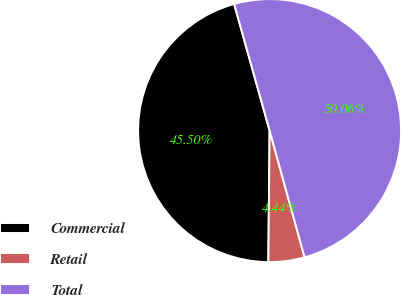Convert chart. <chart><loc_0><loc_0><loc_500><loc_500><pie_chart><fcel>Commercial<fcel>Retail<fcel>Total<nl><fcel>45.5%<fcel>4.44%<fcel>50.06%<nl></chart> 